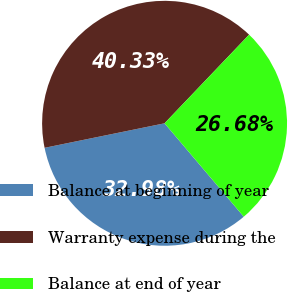Convert chart. <chart><loc_0><loc_0><loc_500><loc_500><pie_chart><fcel>Balance at beginning of year<fcel>Warranty expense during the<fcel>Balance at end of year<nl><fcel>32.98%<fcel>40.33%<fcel>26.68%<nl></chart> 